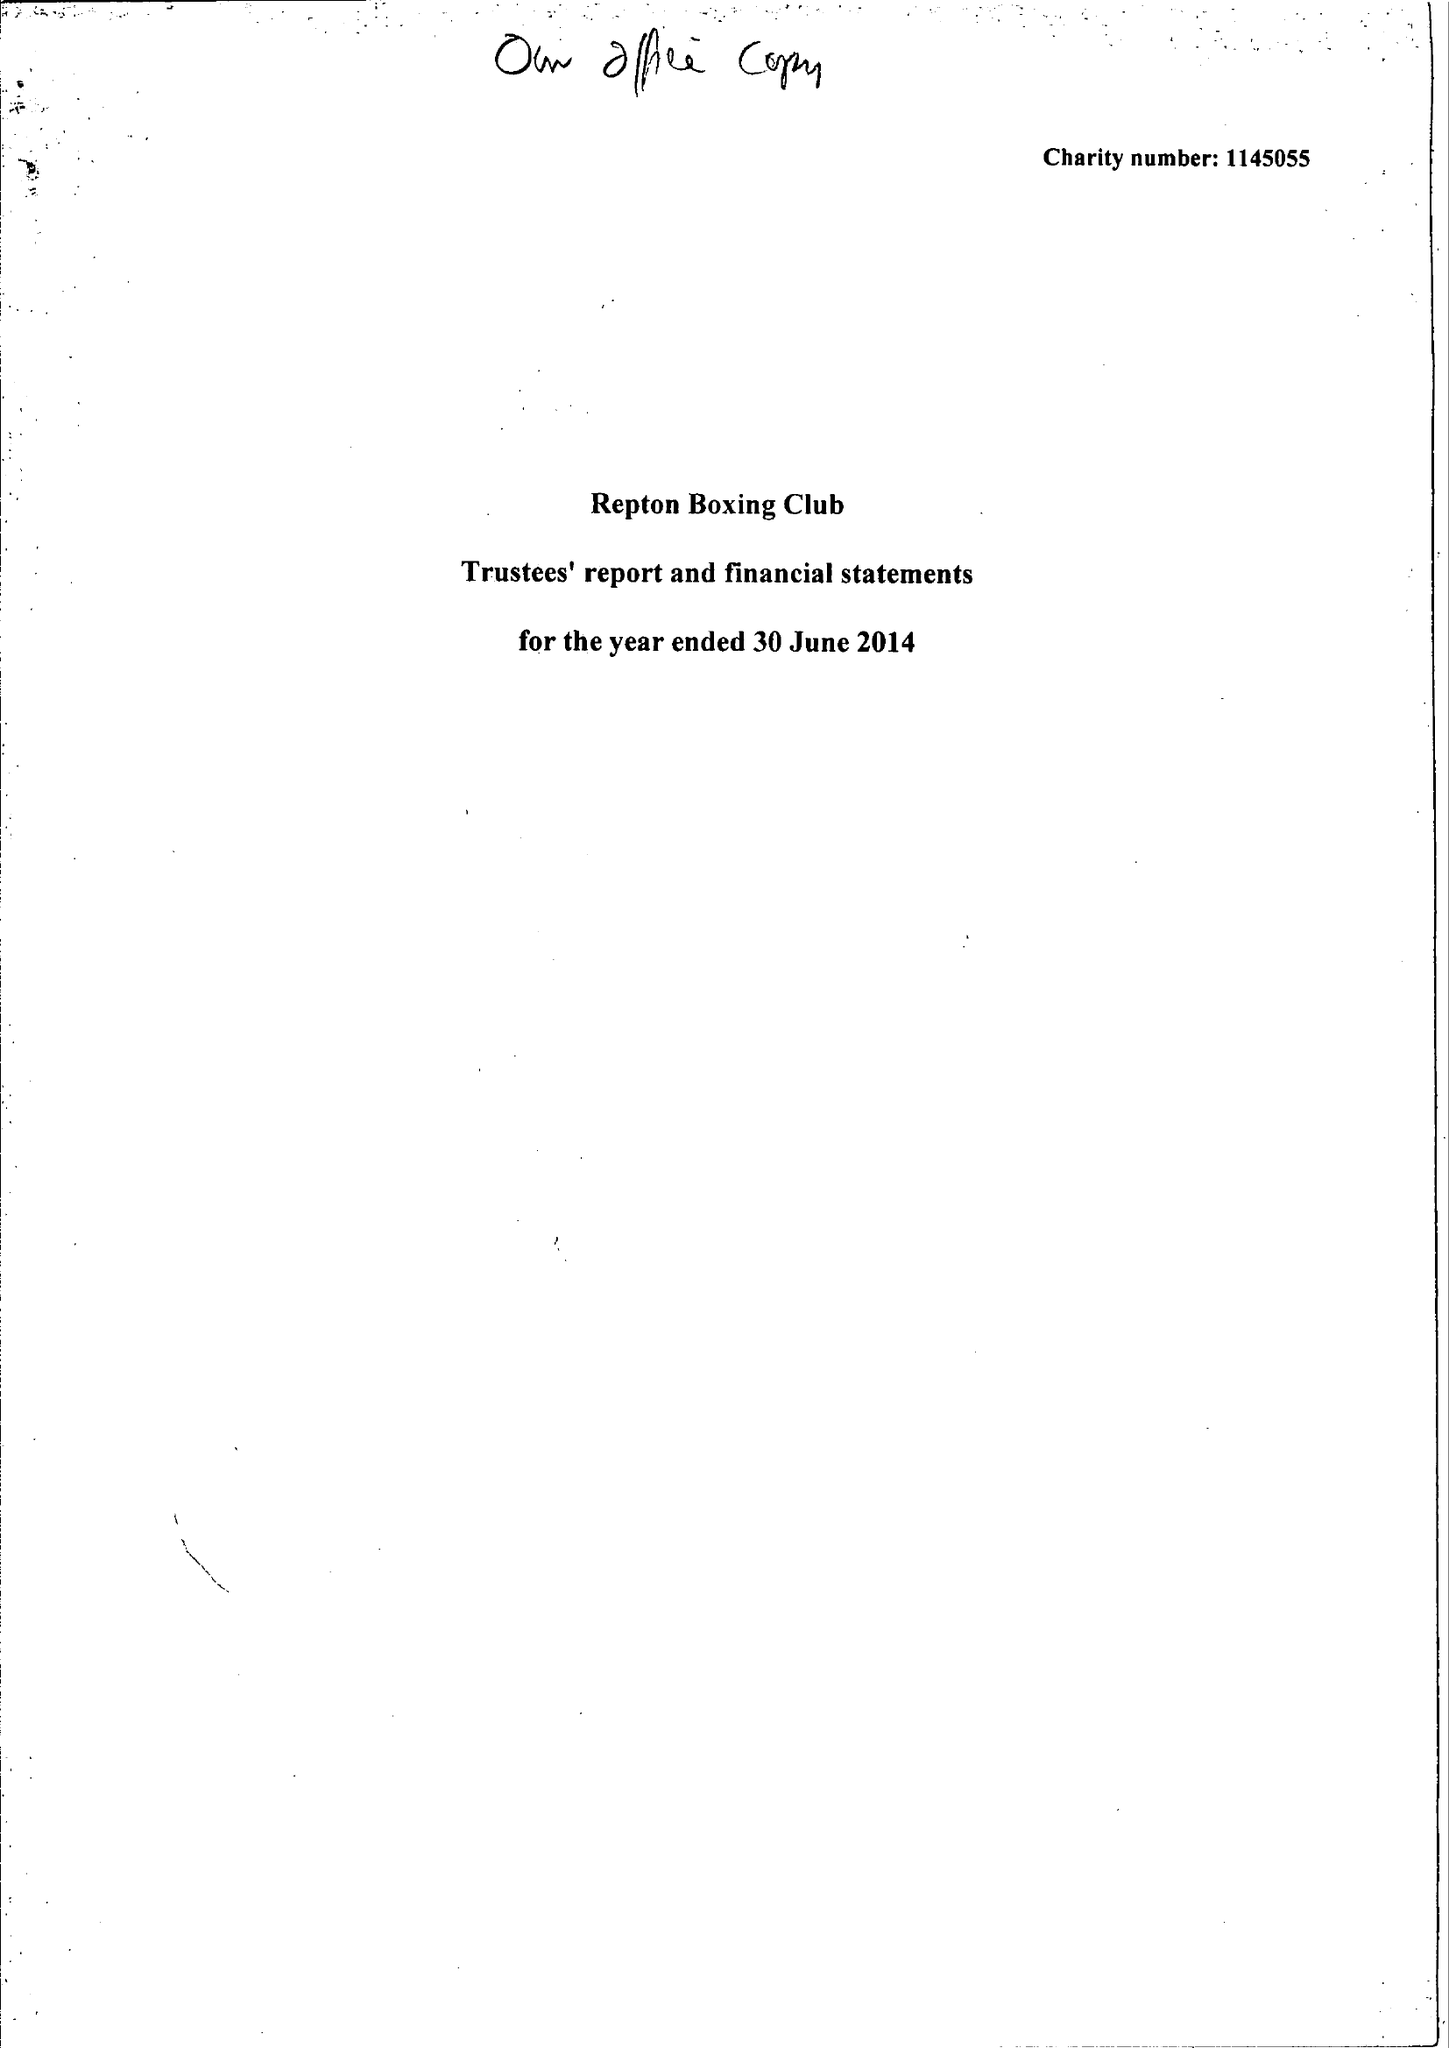What is the value for the address__street_line?
Answer the question using a single word or phrase. 2-10 EZRA STREET 